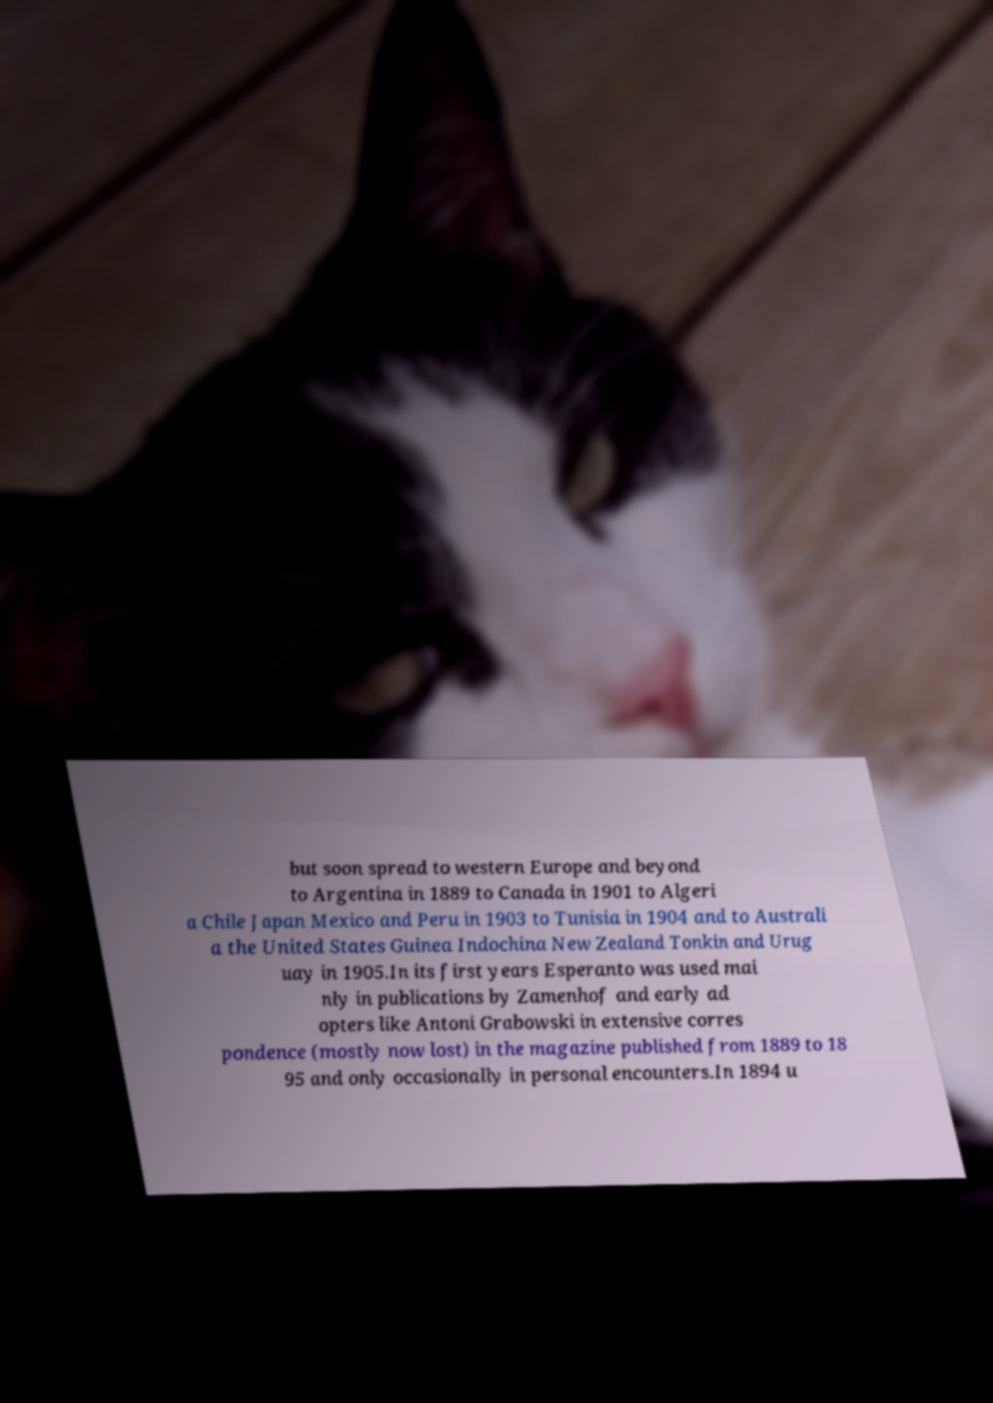What messages or text are displayed in this image? I need them in a readable, typed format. but soon spread to western Europe and beyond to Argentina in 1889 to Canada in 1901 to Algeri a Chile Japan Mexico and Peru in 1903 to Tunisia in 1904 and to Australi a the United States Guinea Indochina New Zealand Tonkin and Urug uay in 1905.In its first years Esperanto was used mai nly in publications by Zamenhof and early ad opters like Antoni Grabowski in extensive corres pondence (mostly now lost) in the magazine published from 1889 to 18 95 and only occasionally in personal encounters.In 1894 u 